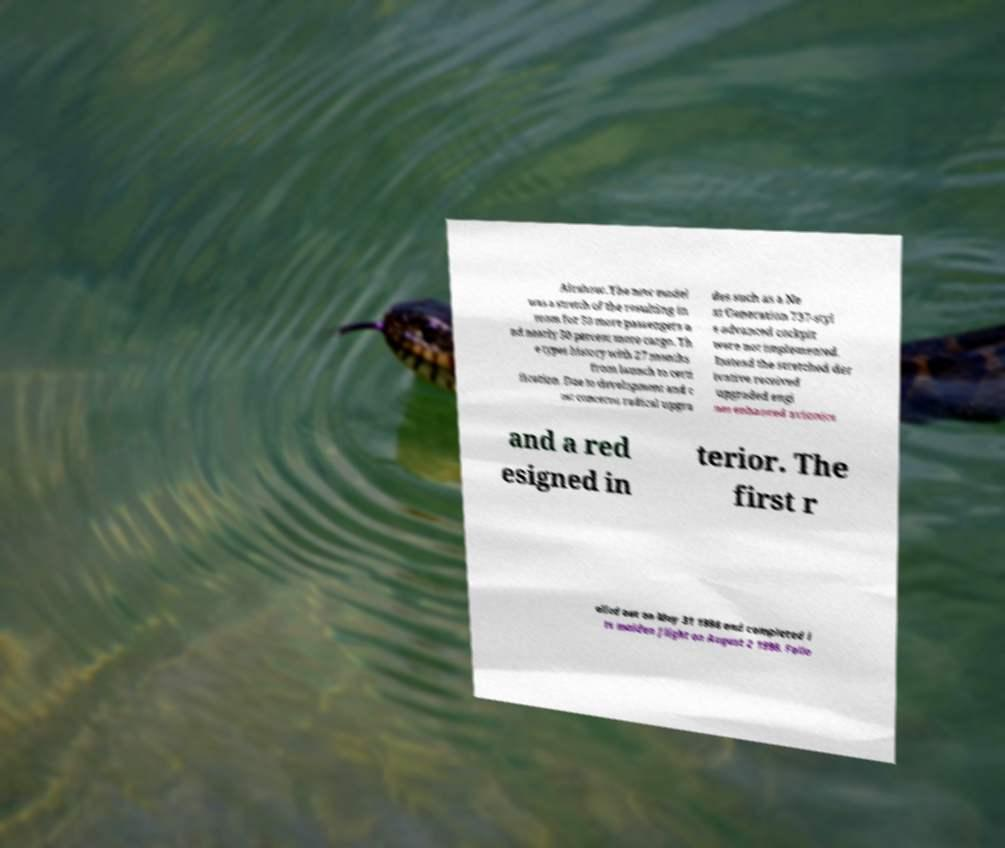Could you assist in decoding the text presented in this image and type it out clearly? Airshow. The new model was a stretch of the resulting in room for 50 more passengers a nd nearly 50 percent more cargo. Th e types history with 27 months from launch to certi fication. Due to development and c ost concerns radical upgra des such as a Ne xt Generation 737-styl e advanced cockpit were not implemented. Instead the stretched der ivative received upgraded engi nes enhanced avionics and a red esigned in terior. The first r olled out on May 31 1998 and completed i ts maiden flight on August 2 1998. Follo 